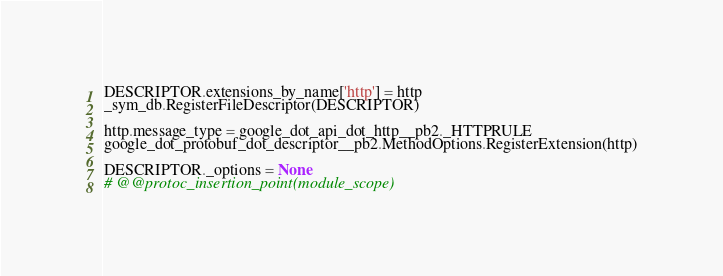Convert code to text. <code><loc_0><loc_0><loc_500><loc_500><_Python_>
DESCRIPTOR.extensions_by_name['http'] = http
_sym_db.RegisterFileDescriptor(DESCRIPTOR)

http.message_type = google_dot_api_dot_http__pb2._HTTPRULE
google_dot_protobuf_dot_descriptor__pb2.MethodOptions.RegisterExtension(http)

DESCRIPTOR._options = None
# @@protoc_insertion_point(module_scope)
</code> 